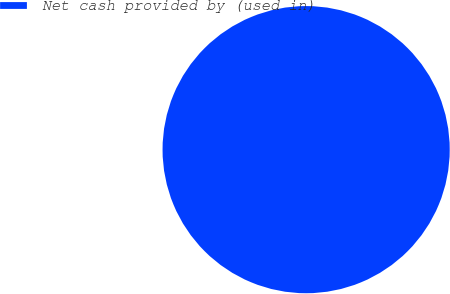Convert chart. <chart><loc_0><loc_0><loc_500><loc_500><pie_chart><fcel>Net cash provided by (used in)<nl><fcel>100.0%<nl></chart> 